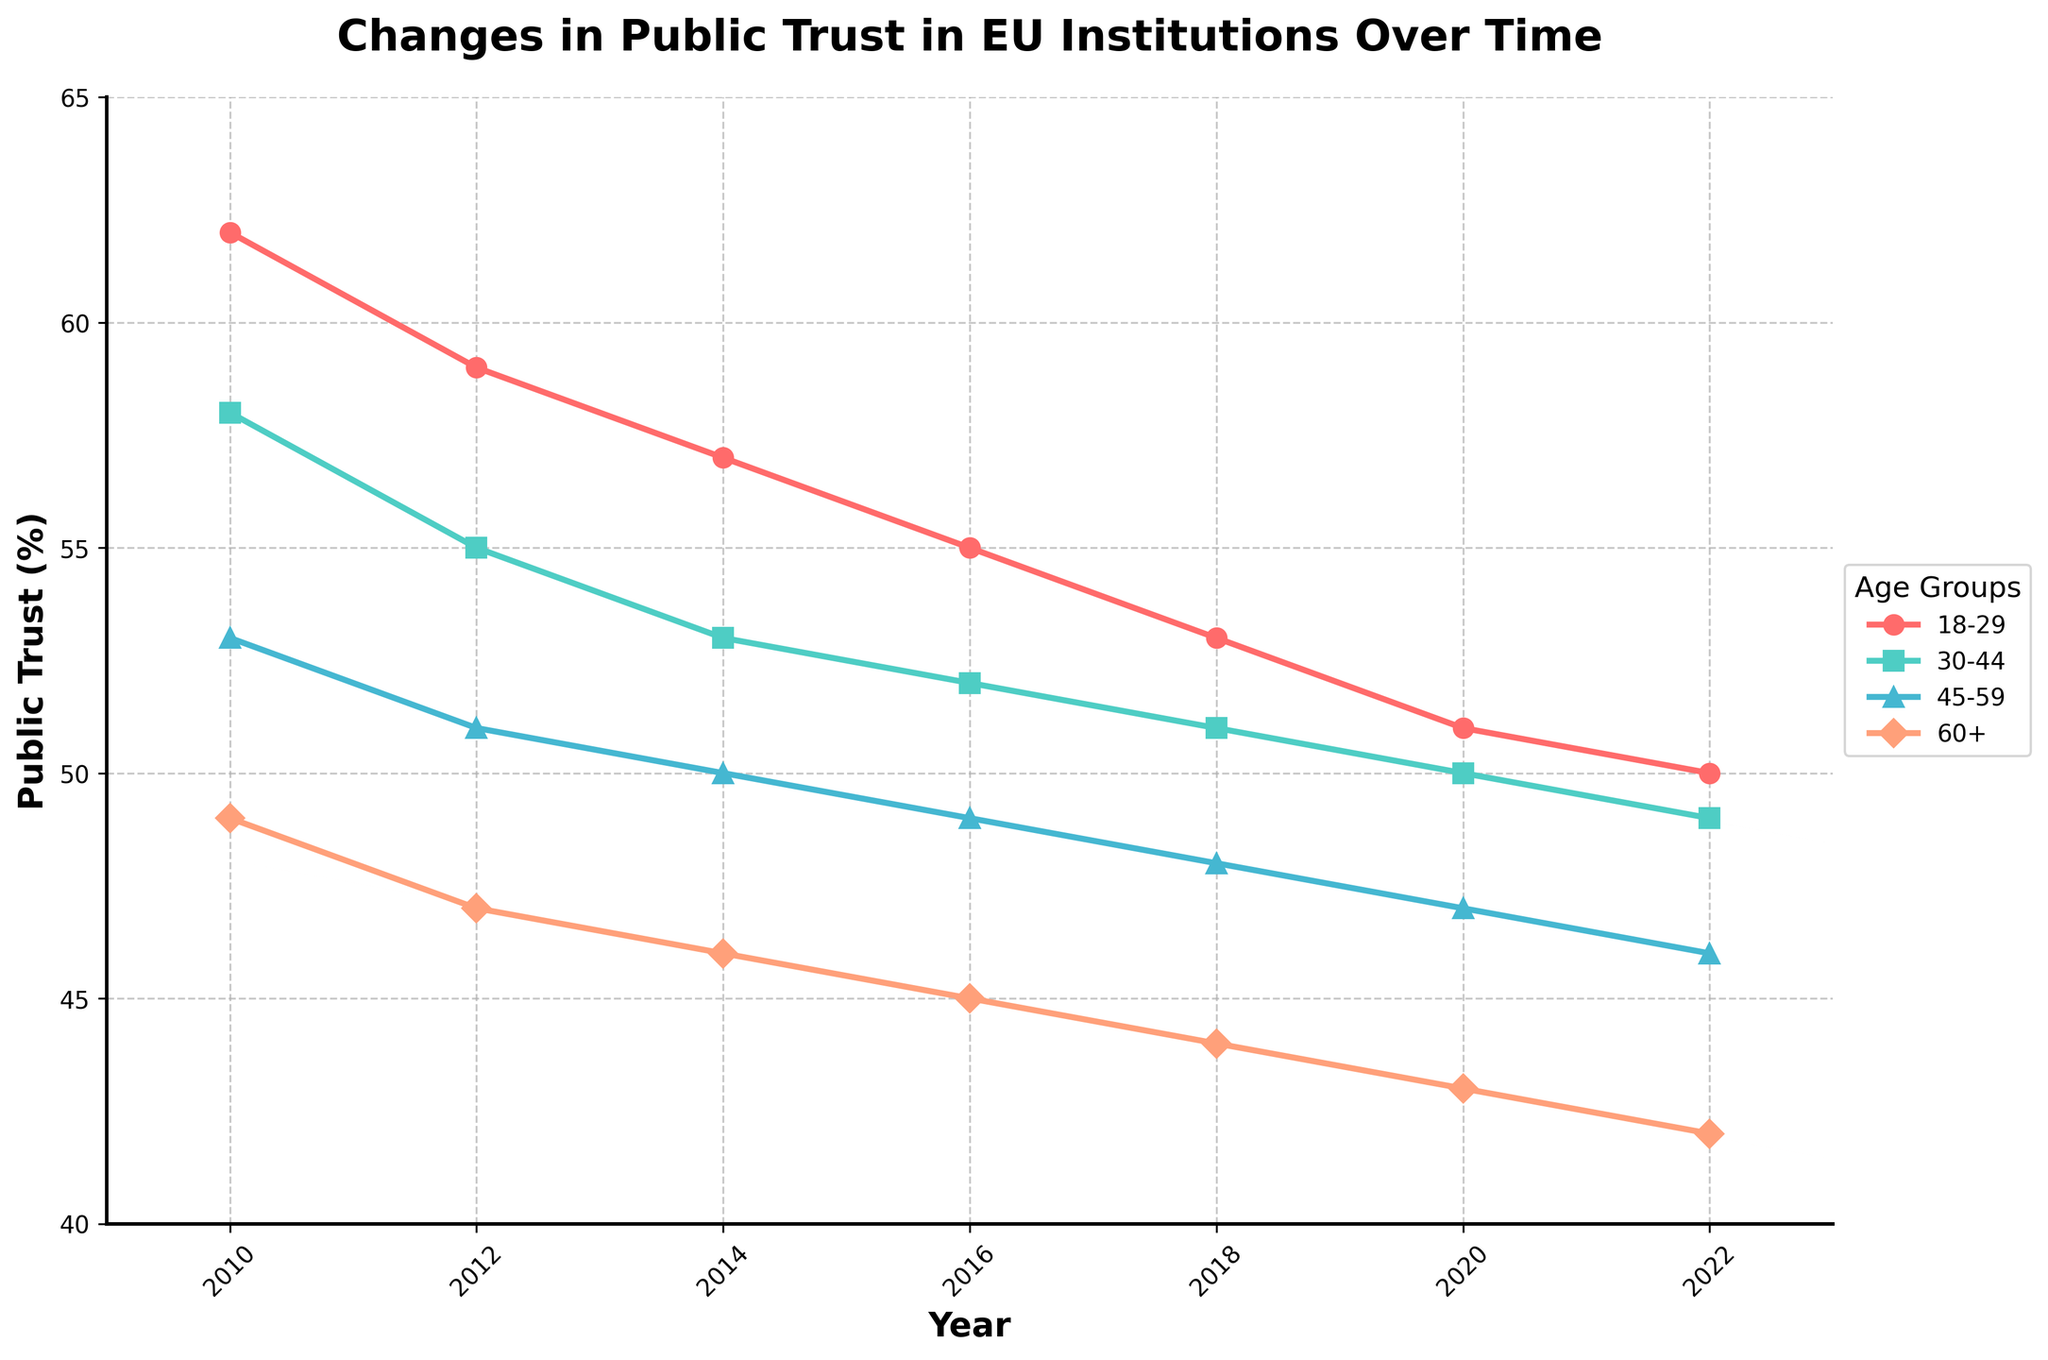Which age group showed the highest public trust in EU institutions in 2010? To identify the group with the highest trust, locate the year 2010 on the x-axis and compare the values for each age group. The group with the highest y-value is the one with the highest trust.
Answer: Age 18-29 Which age group had the lowest public trust in EU institutions in 2020? Locate the year 2020 on the x-axis and identify the corresponding values for each age group. Compare the values, and the lowest value indicates the group with the lowest trust.
Answer: Age 60+ By how much did the public trust in EU institutions for age group 45-59 decrease from 2010 to 2022? Find the values for the 45-59 age group in 2010 and 2022. Subtract the 2022 value from the 2010 value (53 - 46).
Answer: 7 Which age group experienced the greatest decrease in public trust in EU institutions from 2010 to 2022? Calculate the decrease for each age group by subtracting the 2022 value from the 2010 value. Compare the decreases and identify the largest one.
Answer: Age 18-29 Between which consecutive years did the age group 30-44 see the smallest decrease in public trust? Calculate the year-to-year changes for the 30-44 age group and compare them to find the smallest decrease (55-53=2 in 2012-2014).
Answer: 2012-2014 On visual comparison, which line color represents the age group 45-59? Look at the line colors and match them with the colors in the legend to find which color corresponds to the age group 45-59.
Answer: Blue What is the average public trust in EU institutions for the age group 60+ over the shown period? Sum the values for the 60+ age group from 2010 to 2022 and divide by the number of years (49+47+46+45+44+43+42)/7.
Answer: 45.1 Which year did the public trust in EU institutions for the age group 18-29 fall below 60%? Locate the data points for the age group 18-29 and identify the year when the value first drops below 60%.
Answer: 2012 What is the difference in public trust in EU institutions between the youngest and oldest age groups in 2014? Find the 2014 values for age groups 18-29 and 60+. Subtract the 60+ value from the 18-29 value (57 - 46).
Answer: 11 